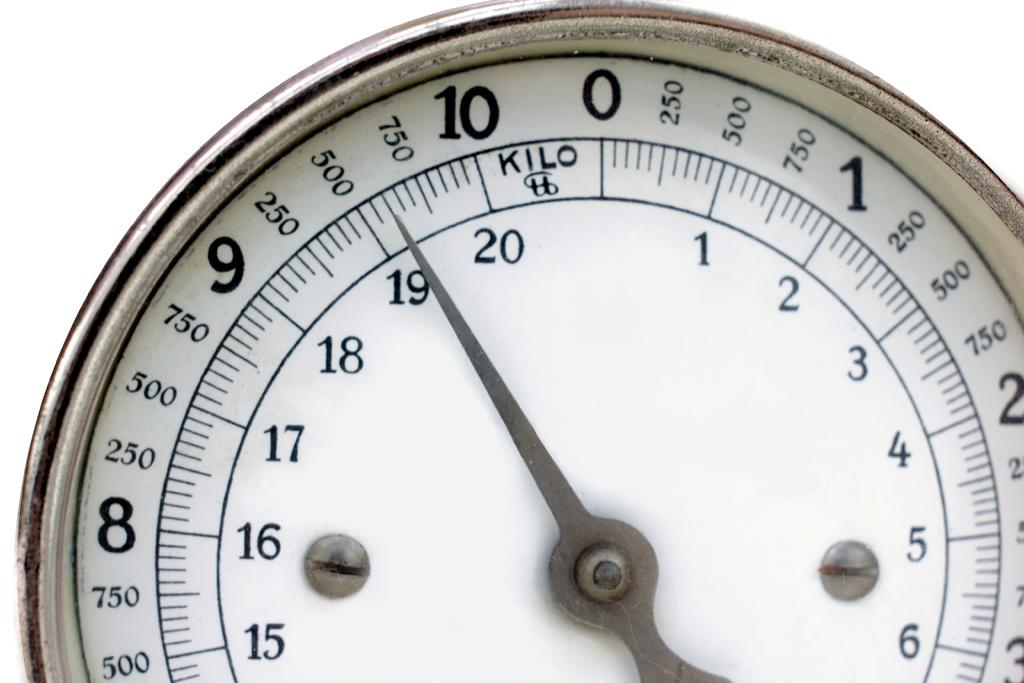<image>
Give a short and clear explanation of the subsequent image. The hand of a gauge is just past 19 Kilos. 